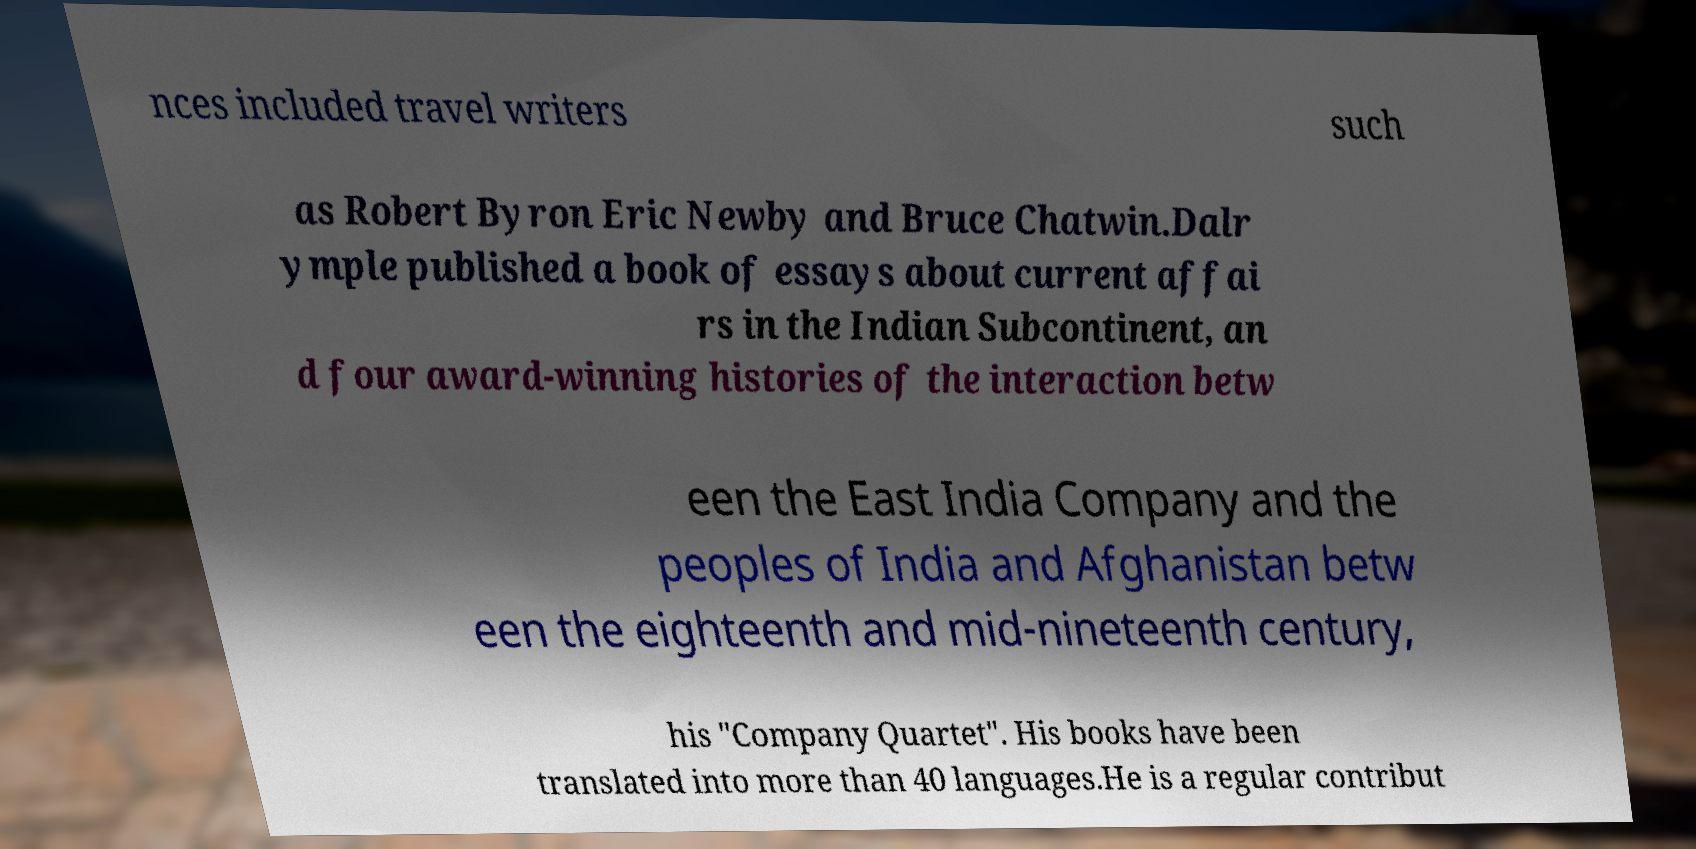Please read and relay the text visible in this image. What does it say? nces included travel writers such as Robert Byron Eric Newby and Bruce Chatwin.Dalr ymple published a book of essays about current affai rs in the Indian Subcontinent, an d four award-winning histories of the interaction betw een the East India Company and the peoples of India and Afghanistan betw een the eighteenth and mid-nineteenth century, his "Company Quartet". His books have been translated into more than 40 languages.He is a regular contribut 